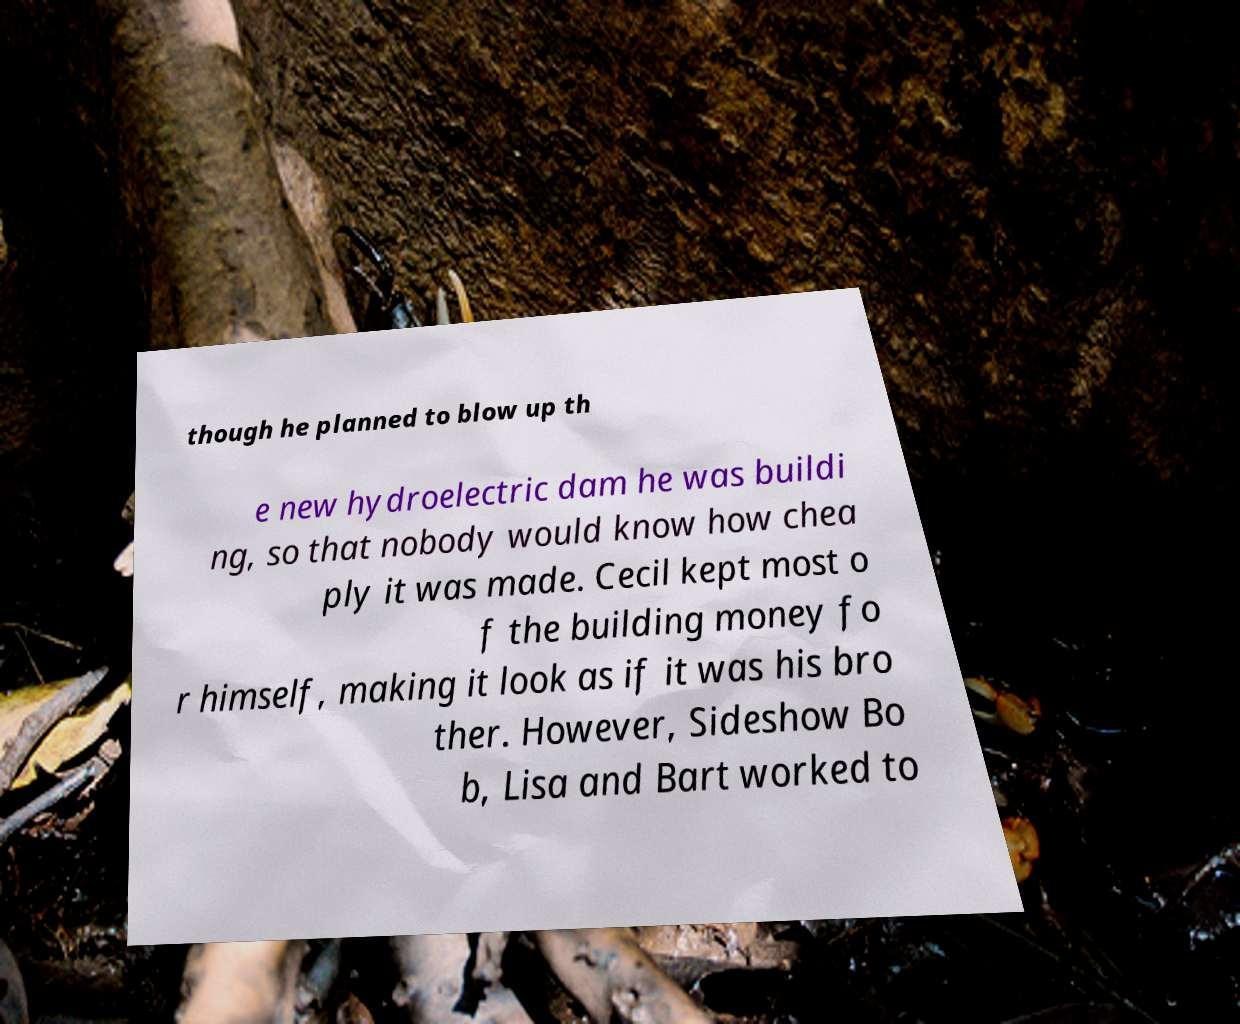Can you read and provide the text displayed in the image?This photo seems to have some interesting text. Can you extract and type it out for me? though he planned to blow up th e new hydroelectric dam he was buildi ng, so that nobody would know how chea ply it was made. Cecil kept most o f the building money fo r himself, making it look as if it was his bro ther. However, Sideshow Bo b, Lisa and Bart worked to 